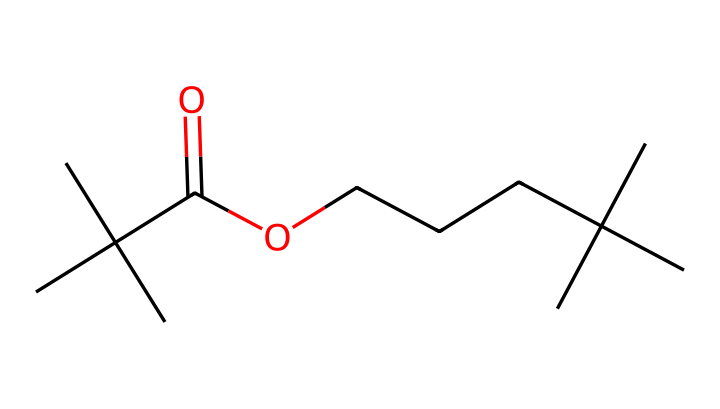What is the primary functional group present in this chemical? The chemical contains a carboxylic acid functional group (denoted by the "C(=O)O" part of the structure), which is characteristic of lipids.
Answer: carboxylic acid How many carbon atoms are in this chemical? By analyzing the SMILES, there are 12 carbon atoms present in total: 4 from the branching at the start and 8 from the long-chain part.
Answer: twelve What type of lipid does this chemical represent? The structure suggests it is a branched-chain fatty acid, commonly found in various lipid compounds.
Answer: branched-chain fatty acid What is the degree of saturation of this lipid? This chemical has no double bonds indicated in its structure, meaning it is fully saturated.
Answer: saturated Does this chemical have any cyclic structures? The provided SMILES does not indicate the presence of any cyclic structures; all carbon atoms are in linear or branched arrangements.
Answer: no What type of interactions would this lipid likely engage in? Given its hydrophobic nature and presence of a long hydrocarbon chain, it would mainly engage in hydrophobic interactions.
Answer: hydrophobic interactions 